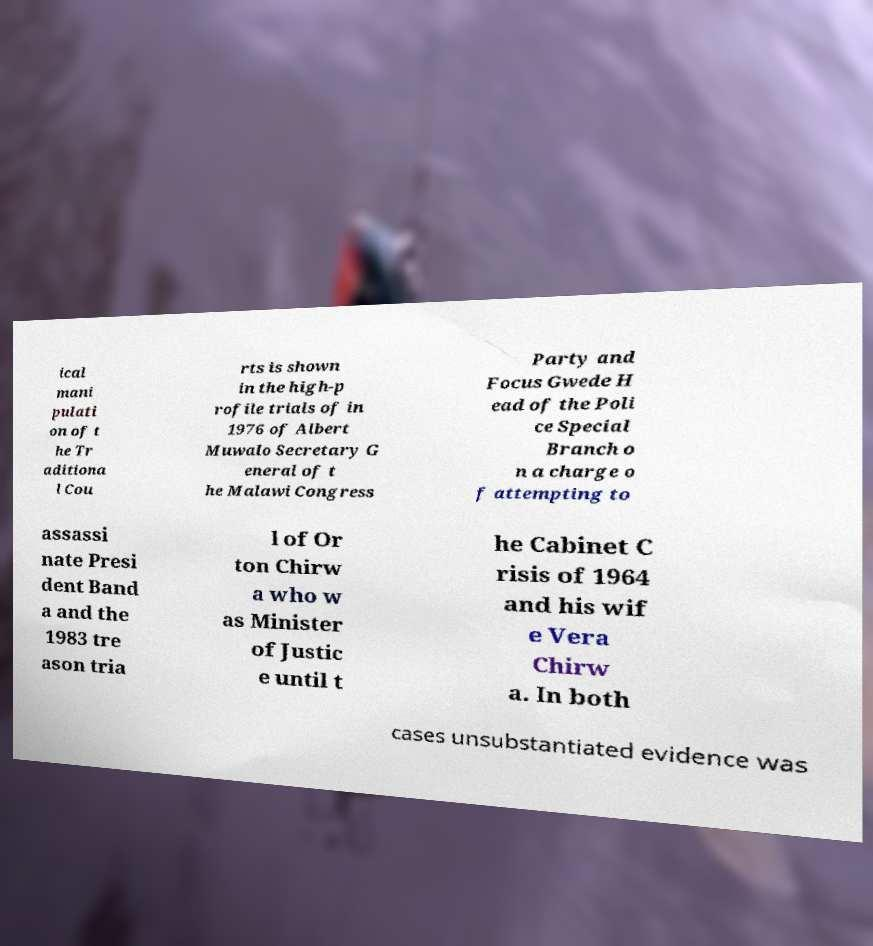Can you accurately transcribe the text from the provided image for me? ical mani pulati on of t he Tr aditiona l Cou rts is shown in the high-p rofile trials of in 1976 of Albert Muwalo Secretary G eneral of t he Malawi Congress Party and Focus Gwede H ead of the Poli ce Special Branch o n a charge o f attempting to assassi nate Presi dent Band a and the 1983 tre ason tria l of Or ton Chirw a who w as Minister of Justic e until t he Cabinet C risis of 1964 and his wif e Vera Chirw a. In both cases unsubstantiated evidence was 